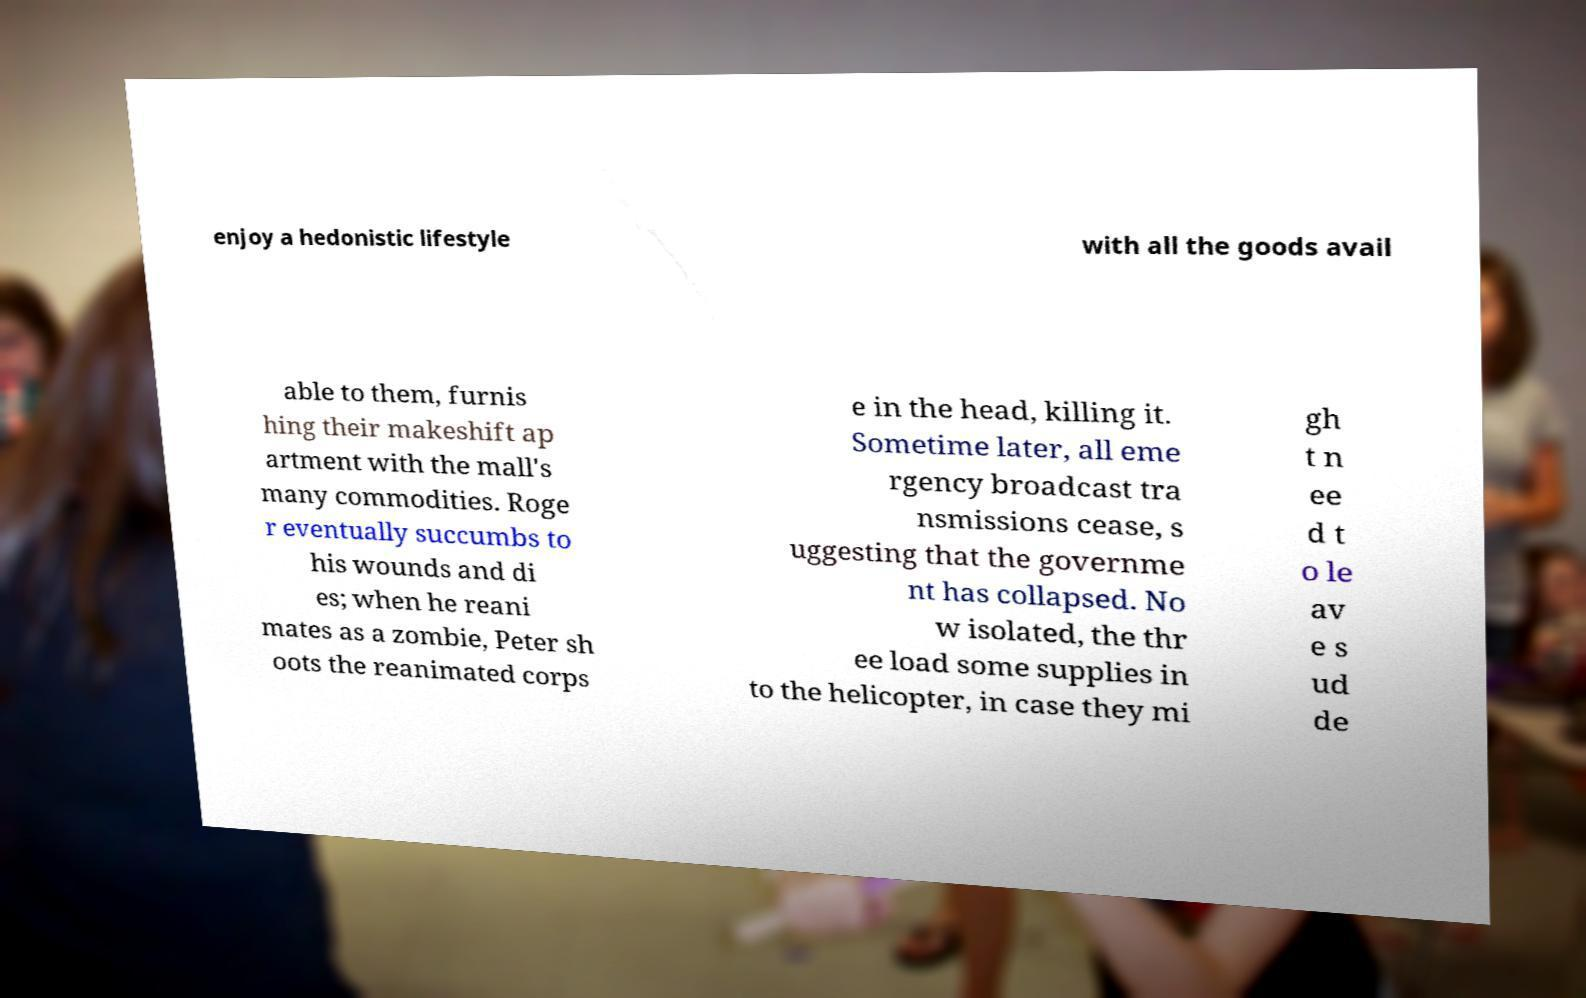For documentation purposes, I need the text within this image transcribed. Could you provide that? enjoy a hedonistic lifestyle with all the goods avail able to them, furnis hing their makeshift ap artment with the mall's many commodities. Roge r eventually succumbs to his wounds and di es; when he reani mates as a zombie, Peter sh oots the reanimated corps e in the head, killing it. Sometime later, all eme rgency broadcast tra nsmissions cease, s uggesting that the governme nt has collapsed. No w isolated, the thr ee load some supplies in to the helicopter, in case they mi gh t n ee d t o le av e s ud de 